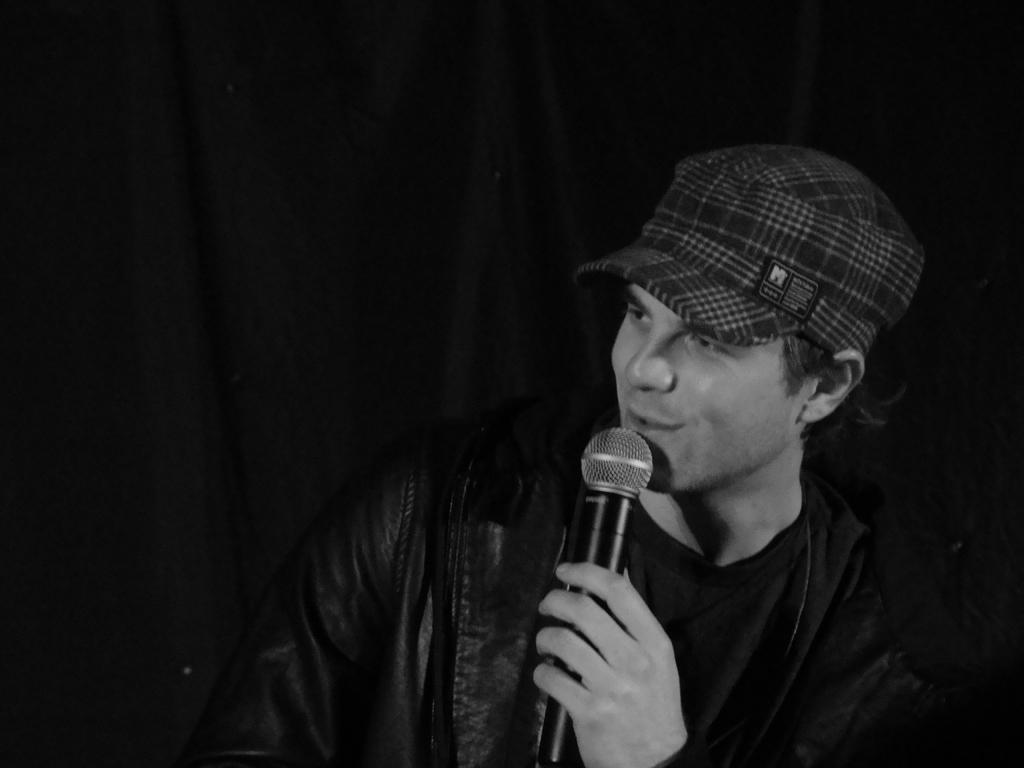Who is the main subject in the image? There is a man in the image. What is the man doing in the image? The man is talking in the image. What object is the man holding in the image? The man is holding a microphone in the image. What can be observed about the background of the image? The background of the image is dark. Is there an earthquake happening in the image? No, there is no indication of an earthquake in the image. Is the man in the image in a prison? There is no indication of a prison in the image; the man is holding a microphone and talking. 